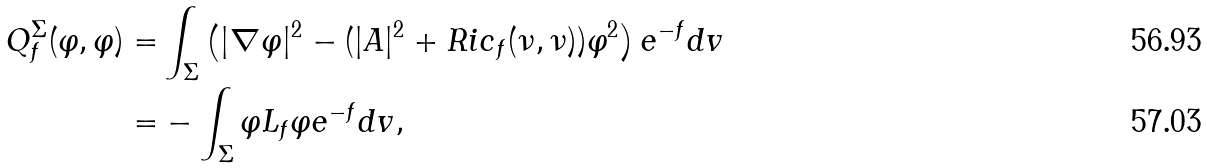Convert formula to latex. <formula><loc_0><loc_0><loc_500><loc_500>Q _ { f } ^ { \Sigma } ( \varphi , \varphi ) = & \int _ { \Sigma } \left ( | \nabla \varphi | ^ { 2 } - ( | A | ^ { 2 } + R i c _ { f } ( \nu , \nu ) ) \varphi ^ { 2 } \right ) e ^ { - f } d v \\ = & - \int _ { \Sigma } \varphi L _ { f } \varphi e ^ { - f } d v ,</formula> 